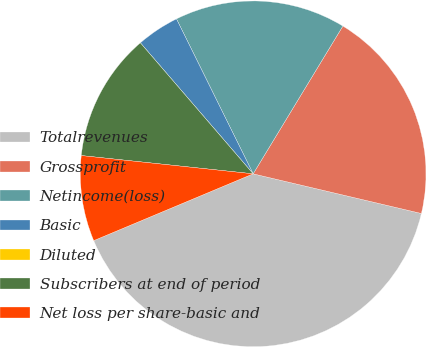Convert chart to OTSL. <chart><loc_0><loc_0><loc_500><loc_500><pie_chart><fcel>Totalrevenues<fcel>Grossprofit<fcel>Netincome(loss)<fcel>Basic<fcel>Diluted<fcel>Subscribers at end of period<fcel>Net loss per share-basic and<nl><fcel>40.0%<fcel>20.0%<fcel>16.0%<fcel>4.0%<fcel>0.0%<fcel>12.0%<fcel>8.0%<nl></chart> 